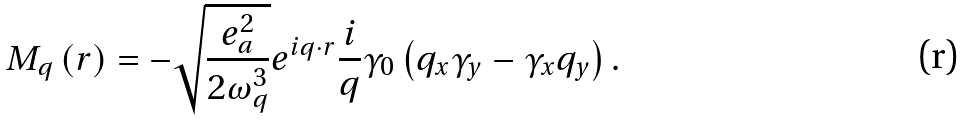<formula> <loc_0><loc_0><loc_500><loc_500>M _ { q } \left ( { r } \right ) = - \sqrt { \frac { e _ { a } ^ { 2 } } { 2 \omega _ { q } ^ { 3 } } } e ^ { i q \cdot { r } } \frac { i } { q } \gamma _ { 0 } \left ( { q _ { x } \gamma _ { y } - \gamma _ { x } q _ { y } } \right ) .</formula> 